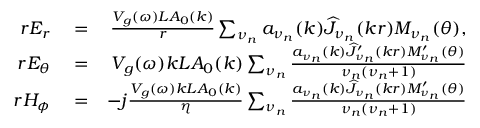Convert formula to latex. <formula><loc_0><loc_0><loc_500><loc_500>\begin{array} { r l r } { r E _ { r } } & = } & { \frac { V _ { g } ( \omega ) L A _ { 0 } ( k ) } { r } \sum _ { \nu _ { n } } a _ { \nu _ { n } } ( k ) \widehat { J } _ { \nu _ { n } } ( k r ) M _ { \nu _ { n } } ( \theta ) , } \\ { r E _ { \theta } } & = } & { V _ { g } ( \omega ) k L A _ { 0 } ( k ) \sum _ { \nu _ { n } } \frac { a _ { \nu _ { n } } ( k ) \widehat { J } _ { \nu _ { n } } ^ { \prime } ( k r ) M _ { \nu _ { n } } ^ { \prime } ( \theta ) } { \nu _ { n } ( \nu _ { n } + 1 ) } } \\ { r H _ { \phi } } & = } & { - j \frac { V _ { g } ( \omega ) k L A _ { 0 } ( k ) } { \eta } \sum _ { \nu _ { n } } \frac { a _ { \nu _ { n } } ( k ) \widehat { J } _ { \nu _ { n } } ( k r ) M _ { \nu _ { n } } ^ { \prime } ( \theta ) } { \nu _ { n } ( \nu _ { n } + 1 ) } } \end{array}</formula> 